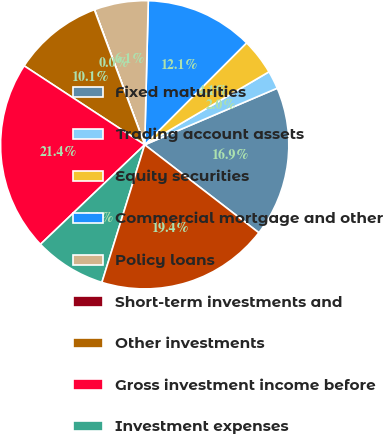Convert chart. <chart><loc_0><loc_0><loc_500><loc_500><pie_chart><fcel>Fixed maturities<fcel>Trading account assets<fcel>Equity securities<fcel>Commercial mortgage and other<fcel>Policy loans<fcel>Short-term investments and<fcel>Other investments<fcel>Gross investment income before<fcel>Investment expenses<fcel>Total investment income<nl><fcel>16.87%<fcel>2.03%<fcel>4.05%<fcel>12.1%<fcel>6.06%<fcel>0.02%<fcel>10.09%<fcel>21.36%<fcel>8.07%<fcel>19.35%<nl></chart> 